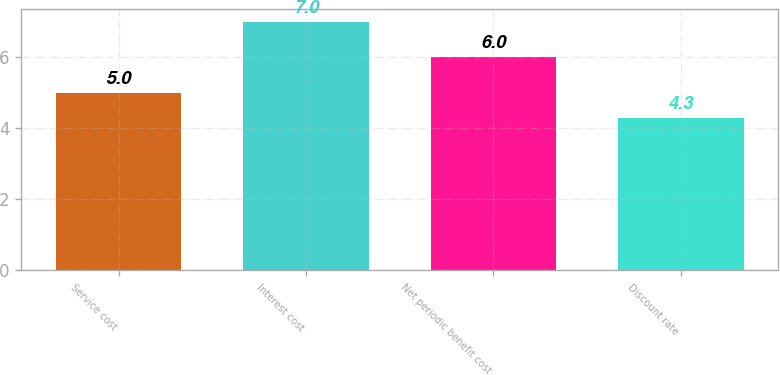Convert chart to OTSL. <chart><loc_0><loc_0><loc_500><loc_500><bar_chart><fcel>Service cost<fcel>Interest cost<fcel>Net periodic benefit cost<fcel>Discount rate<nl><fcel>5<fcel>7<fcel>6<fcel>4.3<nl></chart> 